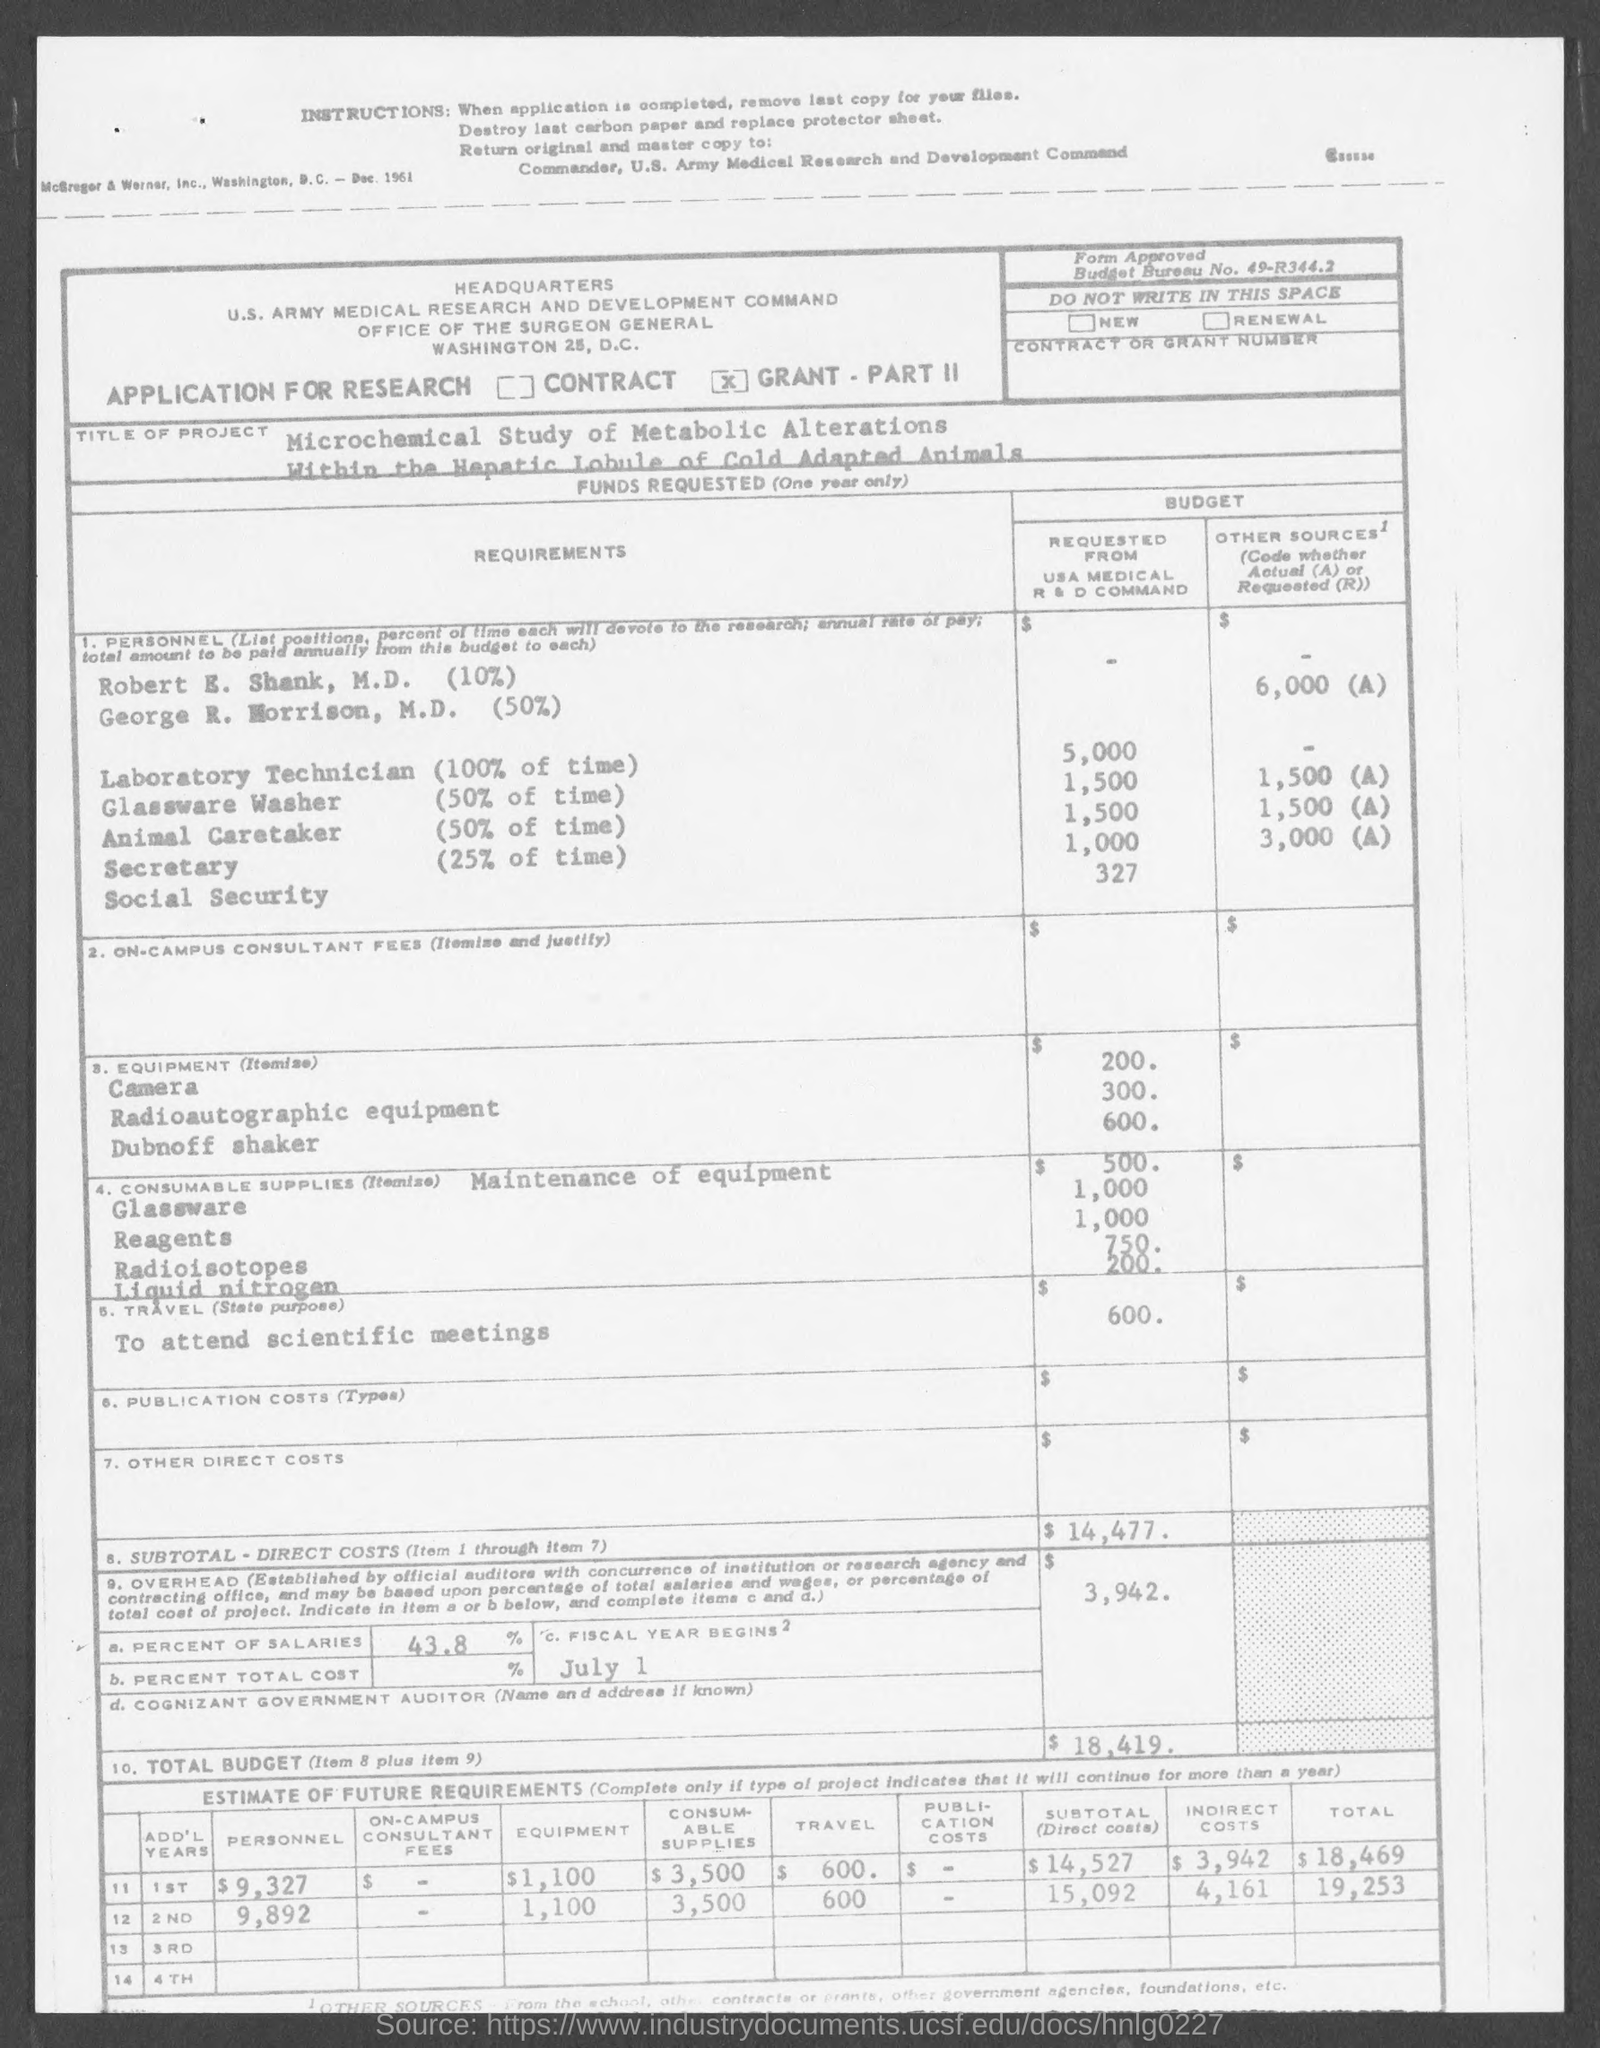Point out several critical features in this image. The United States Medical Research and Development Command has requested a budget of $1,500 for glassware washing equipment. The USA Medical R&D Command is requesting a budget of $1,500 for the care of animals. The USA Medical R&D Command is requesting a budget of $5,000 for a laboratory technician. The title of the project mentioned in the given page is "A Microchemical Study of Metabolic Alterations within the Hepatic Lobule of Cold-Adapted Animals. The percentage of salaries mentioned on the given page is 43.8%. 